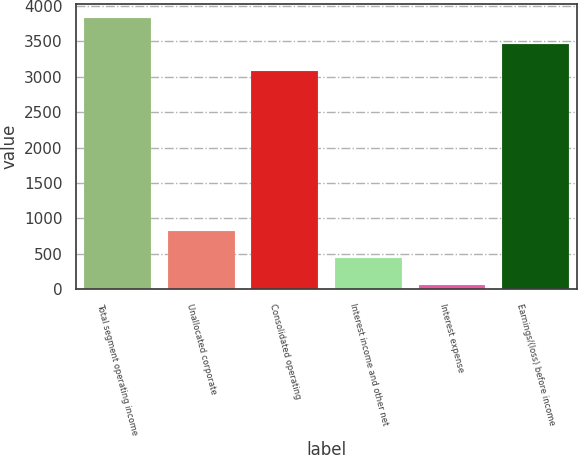Convert chart to OTSL. <chart><loc_0><loc_0><loc_500><loc_500><bar_chart><fcel>Total segment operating income<fcel>Unallocated corporate<fcel>Consolidated operating<fcel>Interest income and other net<fcel>Interest expense<fcel>Earnings/(loss) before income<nl><fcel>3834.5<fcel>817.5<fcel>3081.1<fcel>440.8<fcel>64.1<fcel>3457.8<nl></chart> 